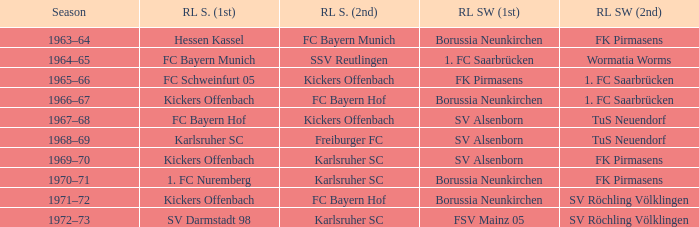What season did SV Darmstadt 98 end up at RL Süd (1st)? 1972–73. 